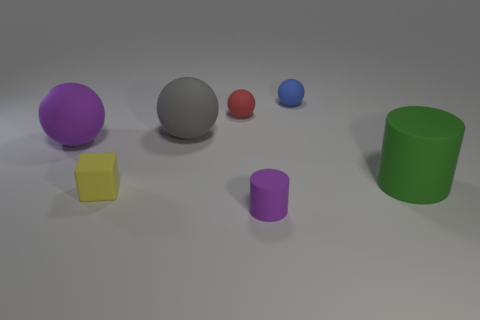Is the small purple cylinder made of the same material as the small yellow block?
Offer a terse response. Yes. How many objects are large things that are behind the big matte cylinder or tiny rubber things that are right of the gray matte object?
Provide a short and direct response. 5. What is the color of the other big matte thing that is the same shape as the large purple matte object?
Offer a very short reply. Gray. How many other large matte cylinders have the same color as the big cylinder?
Ensure brevity in your answer.  0. How many things are either matte spheres in front of the big gray matte ball or small green shiny cylinders?
Your answer should be compact. 1. There is a ball in front of the big rubber sphere to the right of the purple object on the left side of the tiny yellow object; what color is it?
Your answer should be very brief. Purple. There is a tiny cylinder that is made of the same material as the large gray ball; what is its color?
Keep it short and to the point. Purple. What number of small purple objects have the same material as the purple ball?
Keep it short and to the point. 1. There is a purple object that is behind the purple matte cylinder; does it have the same size as the green thing?
Offer a very short reply. Yes. There is a matte cylinder that is the same size as the gray sphere; what color is it?
Give a very brief answer. Green. 